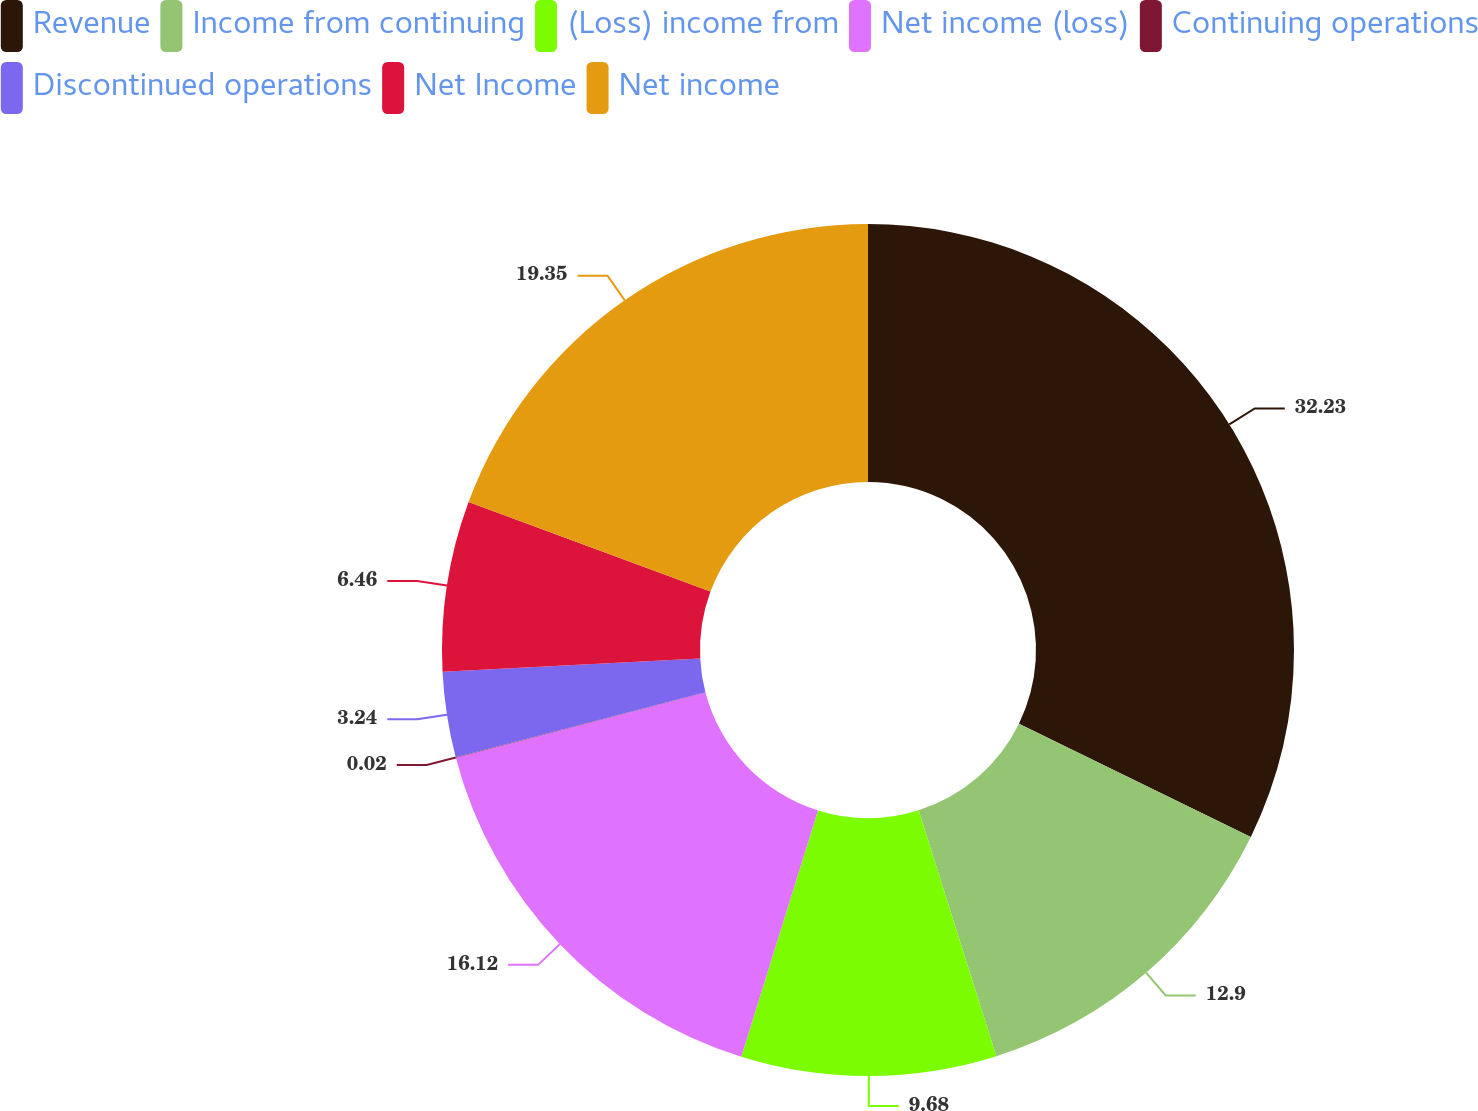Convert chart to OTSL. <chart><loc_0><loc_0><loc_500><loc_500><pie_chart><fcel>Revenue<fcel>Income from continuing<fcel>(Loss) income from<fcel>Net income (loss)<fcel>Continuing operations<fcel>Discontinued operations<fcel>Net Income<fcel>Net income<nl><fcel>32.23%<fcel>12.9%<fcel>9.68%<fcel>16.12%<fcel>0.02%<fcel>3.24%<fcel>6.46%<fcel>19.35%<nl></chart> 